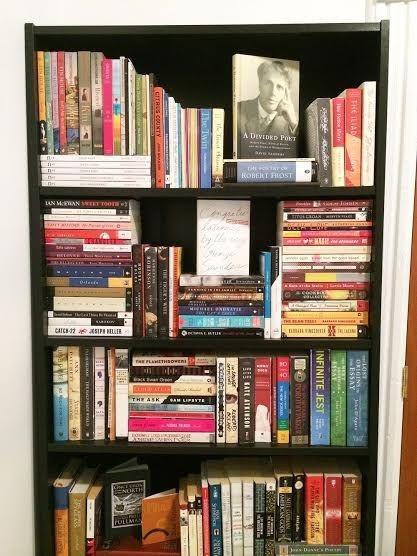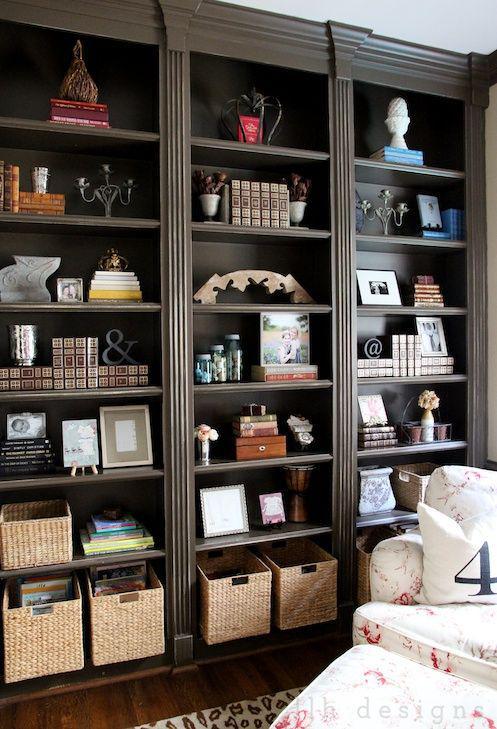The first image is the image on the left, the second image is the image on the right. Analyze the images presented: Is the assertion "In one image, at least one lamp and seating are next to a shelving unit." valid? Answer yes or no. No. The first image is the image on the left, the second image is the image on the right. Analyze the images presented: Is the assertion "An image includes at least one dark bookcase." valid? Answer yes or no. Yes. 